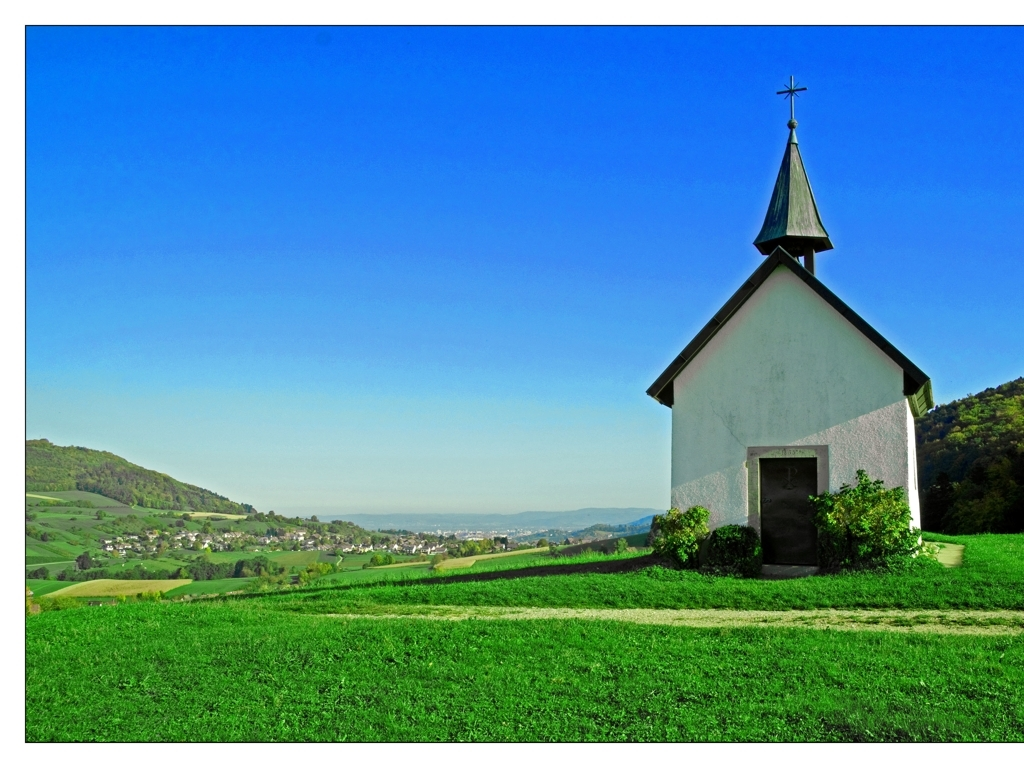Does the image have sufficient lighting?
 Yes 